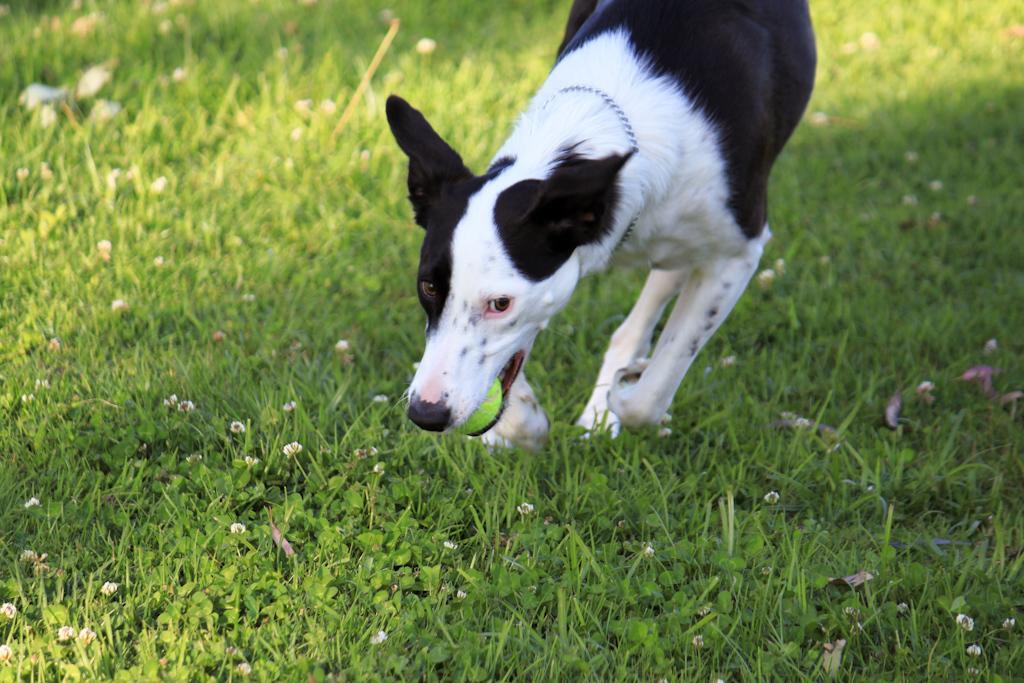Describe this image in one or two sentences. In this image there is a dog holding the ball in her mouth. At the bottom of the image there is grass on the surface. 